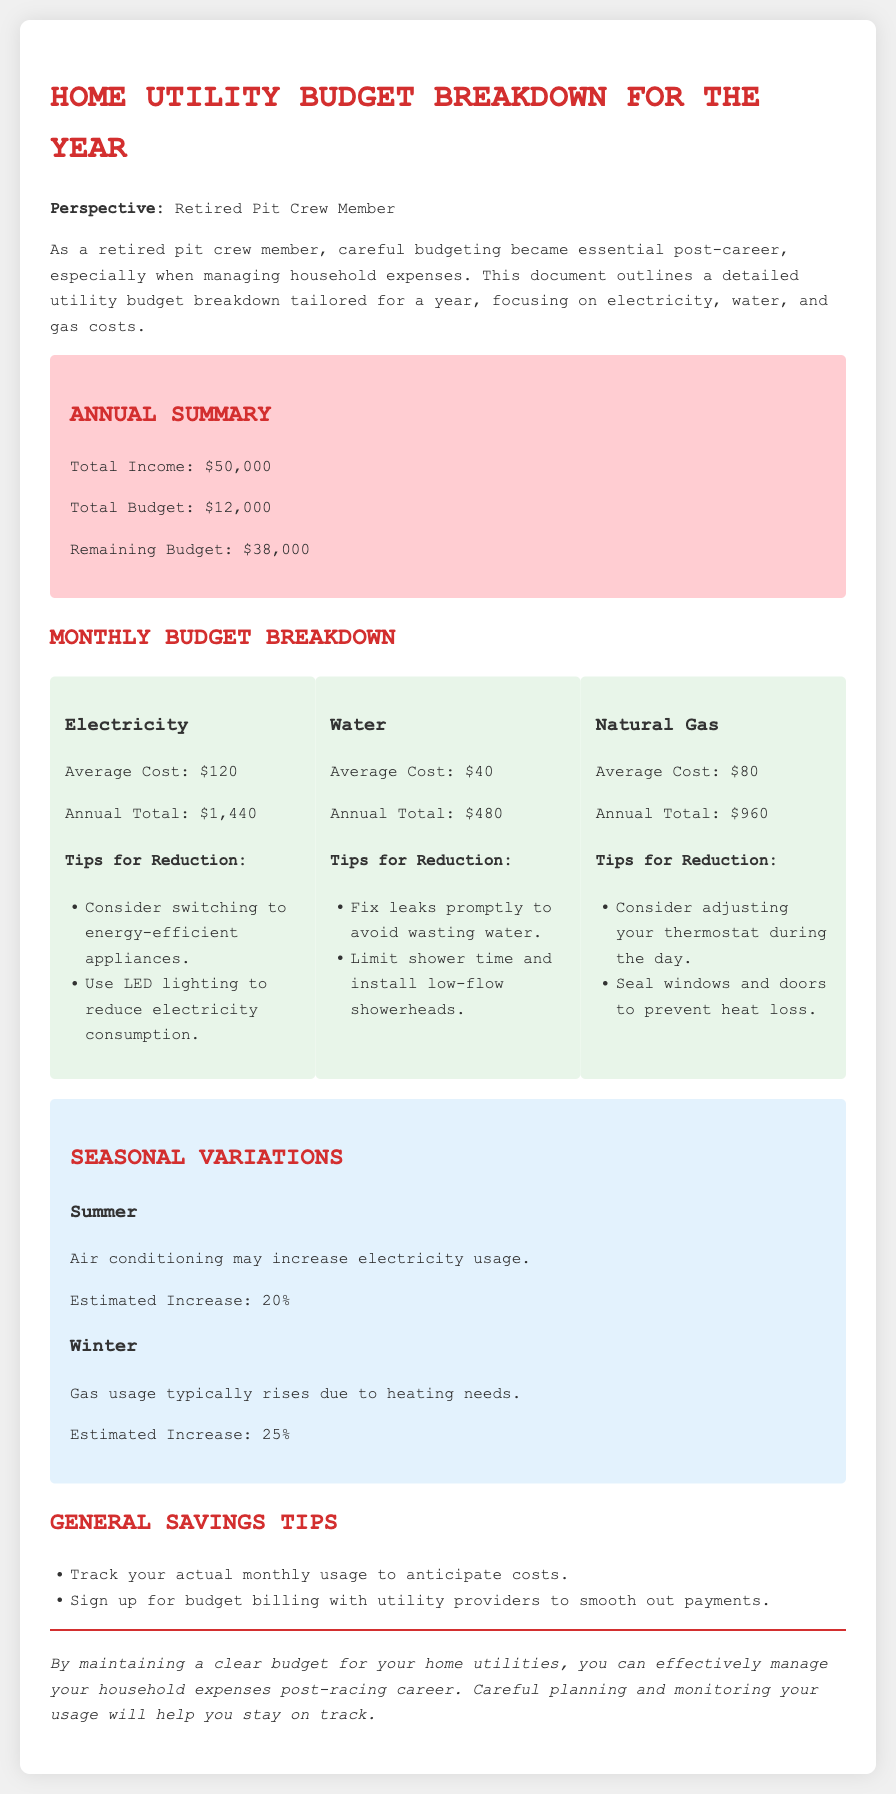What is the total income? The total income is stated directly in the document as $50,000.
Answer: $50,000 What is the annual total cost for electricity? The annual total cost for electricity is provided in the breakdown, which is $1,440.
Answer: $1,440 What are the average monthly water costs? The document specifies that the average cost for water is $40 per month.
Answer: $40 What tips are provided for reducing electricity costs? There are two specific tips mentioned in the electricity section for reduction purposes; these tips are to switch to energy-efficient appliances and use LED lighting.
Answer: Switch to energy-efficient appliances; use LED lighting By how much is electricity estimated to increase during the summer? The document states that electricity usage may increase by an estimated 20% during the summer.
Answer: 20% What is the total budget for home utilities? The total budget allocated for home utilities is detailed as $12,000 in the summary section.
Answer: $12,000 What seasonal variation affects gas usage? The document explains that gas usage typically rises due to heating needs in winter.
Answer: Winter What general savings tips are given in the document? The tips include tracking actual monthly usage and signing up for budget billing with utility providers.
Answer: Track actual monthly usage; sign up for budget billing 